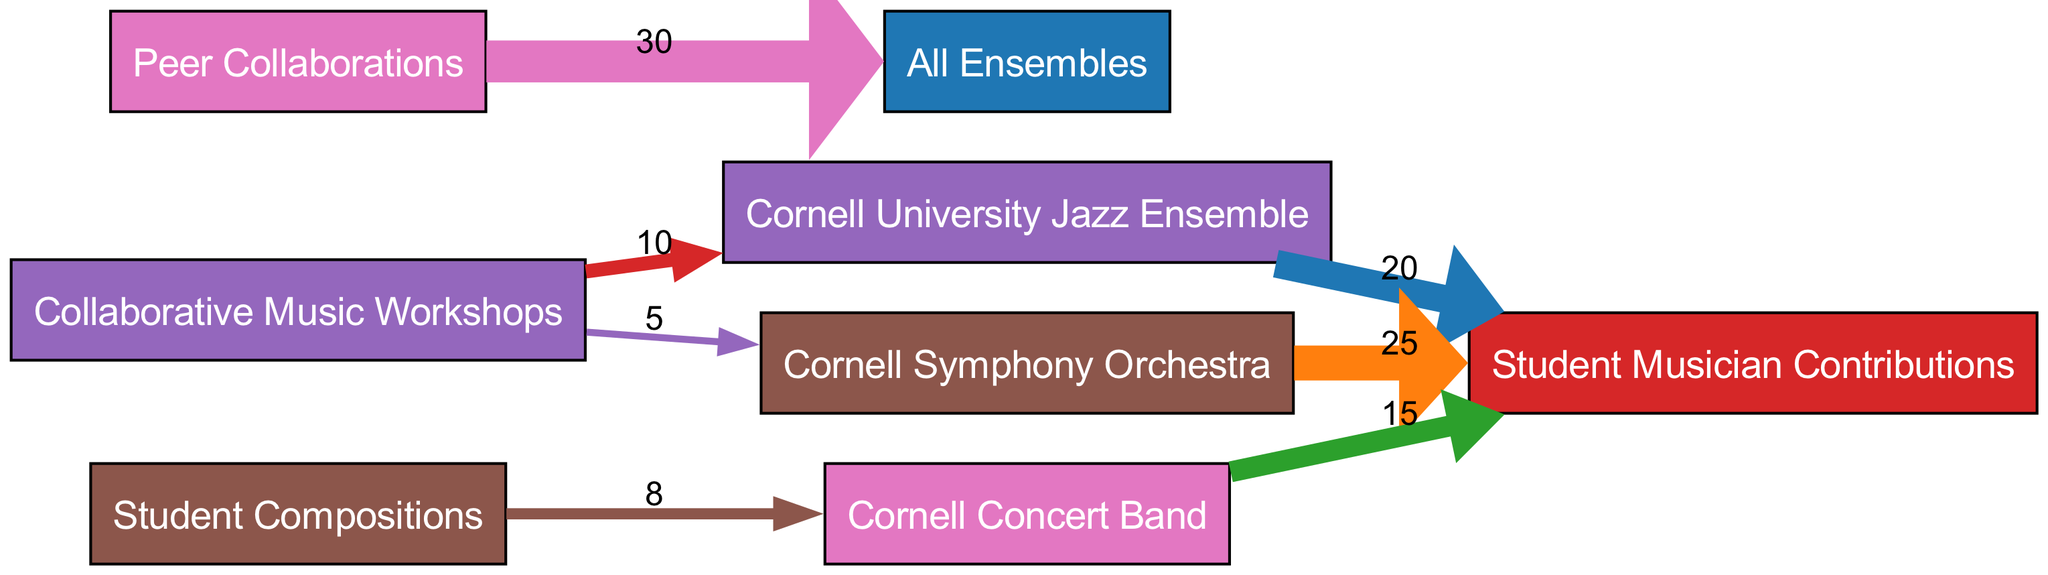What is the total contribution from the Cornell Symphony Orchestra? The diagram indicates that the value flowing from the Cornell Symphony Orchestra to Student Musician Contributions is 25. Therefore, the total contribution is directly taken from that value.
Answer: 25 How many collaborations come from Peer Collaborations to All Ensembles? According to the diagram, the value from Peer Collaborations leading to All Ensembles is 30, which represents the total collaborative efforts from that source.
Answer: 30 Which ensemble has the highest contribution from student musicians? By examining the values associated with each ensemble's contribution to Student Musician Contributions, the Cornell Symphony Orchestra has the highest value of 25 compared to the others (20 for Jazz Ensemble and 15 for Concert Band).
Answer: Cornell Symphony Orchestra What is the flow value from Collaborative Music Workshops to the Cornell Concert Band? The diagram shows that Collaborative Music Workshops contribute a value of 0 in the flow to the Cornell Concert Band, meaning no contributions are indicated from that source to this ensemble.
Answer: 0 Which node has the least flow towards Student Musician Contributions? The contribution values for the ensembles indicate that the Cornell Concert Band has the least flow, with a value of 15 compared to the other's contributions (20 from Jazz Ensemble and 25 from Symphony Orchestra).
Answer: Cornell Concert Band How many total contributions do the Collaborative Music Workshops provide? Adding the flow values from Collaborative Music Workshops, there are contributions of 10 to the Cornell University Jazz Ensemble and 5 to the Cornell Symphony Orchestra, totaling 15.
Answer: 15 What is the total number of nodes present in this diagram? The diagram lists multiple sources and targets: 4 different source ensembles and 3 target categories, resulting in a total of 7 distinct nodes in the visual representation.
Answer: 7 Which ensemble benefits most from student compositions? The flow from Student Compositions to Cornell Concert Band is 8, the only value indicating the benefit from this source, making it the sole beneficiary.
Answer: Cornell Concert Band 